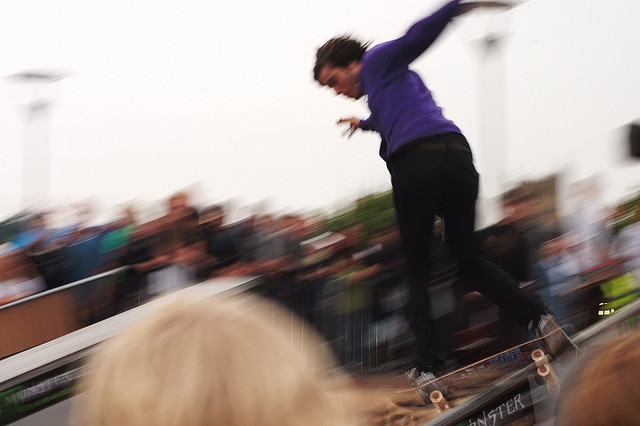Identify and read out the text in this image. NSTER 